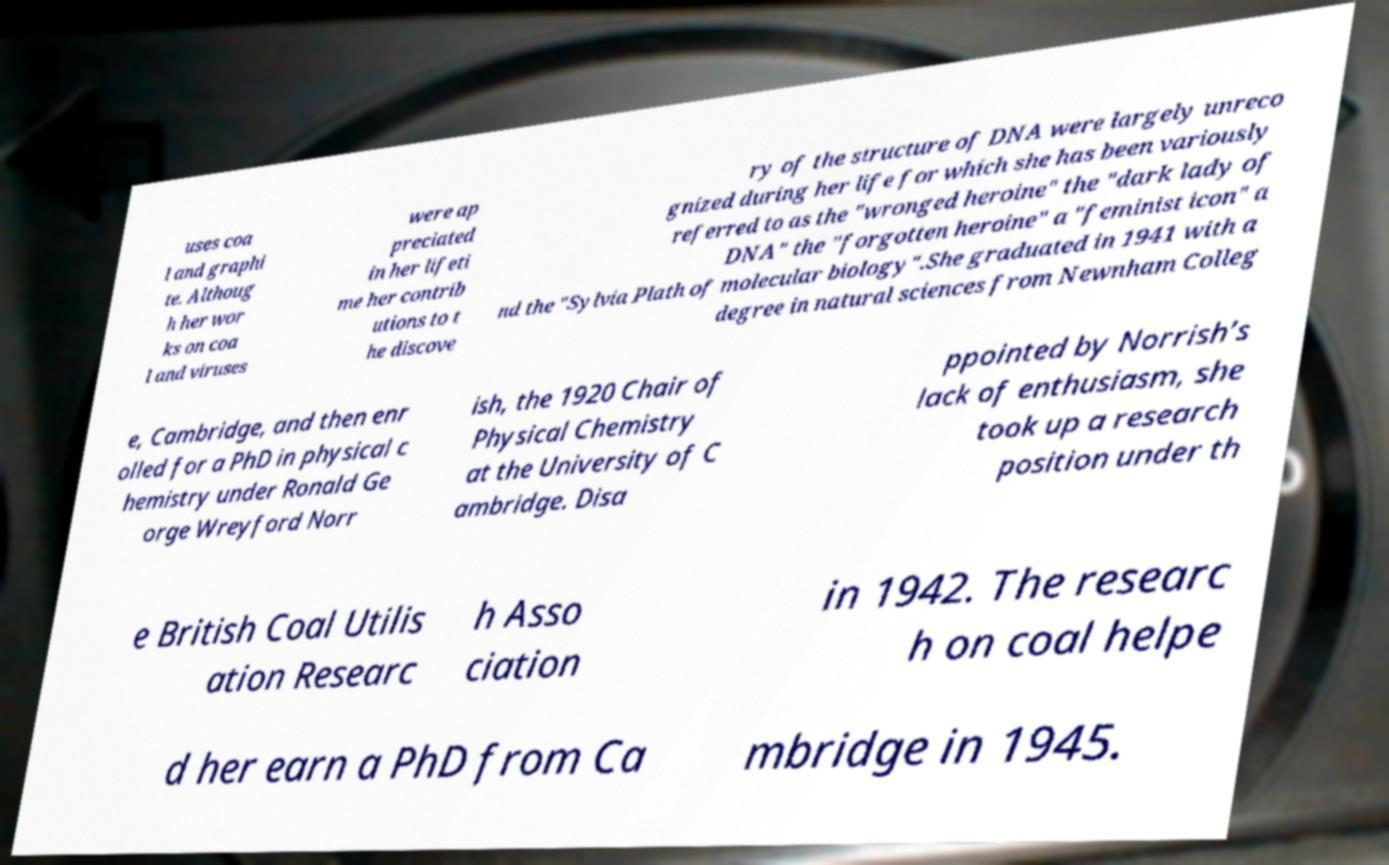For documentation purposes, I need the text within this image transcribed. Could you provide that? uses coa l and graphi te. Althoug h her wor ks on coa l and viruses were ap preciated in her lifeti me her contrib utions to t he discove ry of the structure of DNA were largely unreco gnized during her life for which she has been variously referred to as the "wronged heroine" the "dark lady of DNA" the "forgotten heroine" a "feminist icon" a nd the "Sylvia Plath of molecular biology".She graduated in 1941 with a degree in natural sciences from Newnham Colleg e, Cambridge, and then enr olled for a PhD in physical c hemistry under Ronald Ge orge Wreyford Norr ish, the 1920 Chair of Physical Chemistry at the University of C ambridge. Disa ppointed by Norrish’s lack of enthusiasm, she took up a research position under th e British Coal Utilis ation Researc h Asso ciation in 1942. The researc h on coal helpe d her earn a PhD from Ca mbridge in 1945. 